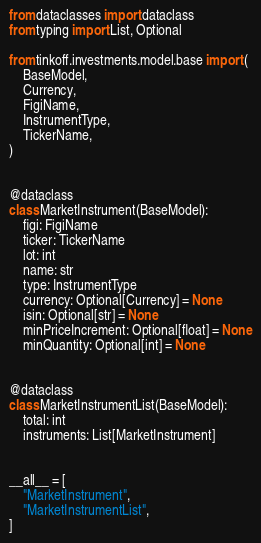<code> <loc_0><loc_0><loc_500><loc_500><_Python_>from dataclasses import dataclass
from typing import List, Optional

from tinkoff.investments.model.base import (
    BaseModel,
    Currency,
    FigiName,
    InstrumentType,
    TickerName,
)


@dataclass
class MarketInstrument(BaseModel):
    figi: FigiName
    ticker: TickerName
    lot: int
    name: str
    type: InstrumentType
    currency: Optional[Currency] = None
    isin: Optional[str] = None
    minPriceIncrement: Optional[float] = None
    minQuantity: Optional[int] = None


@dataclass
class MarketInstrumentList(BaseModel):
    total: int
    instruments: List[MarketInstrument]


__all__ = [
    "MarketInstrument",
    "MarketInstrumentList",
]
</code> 